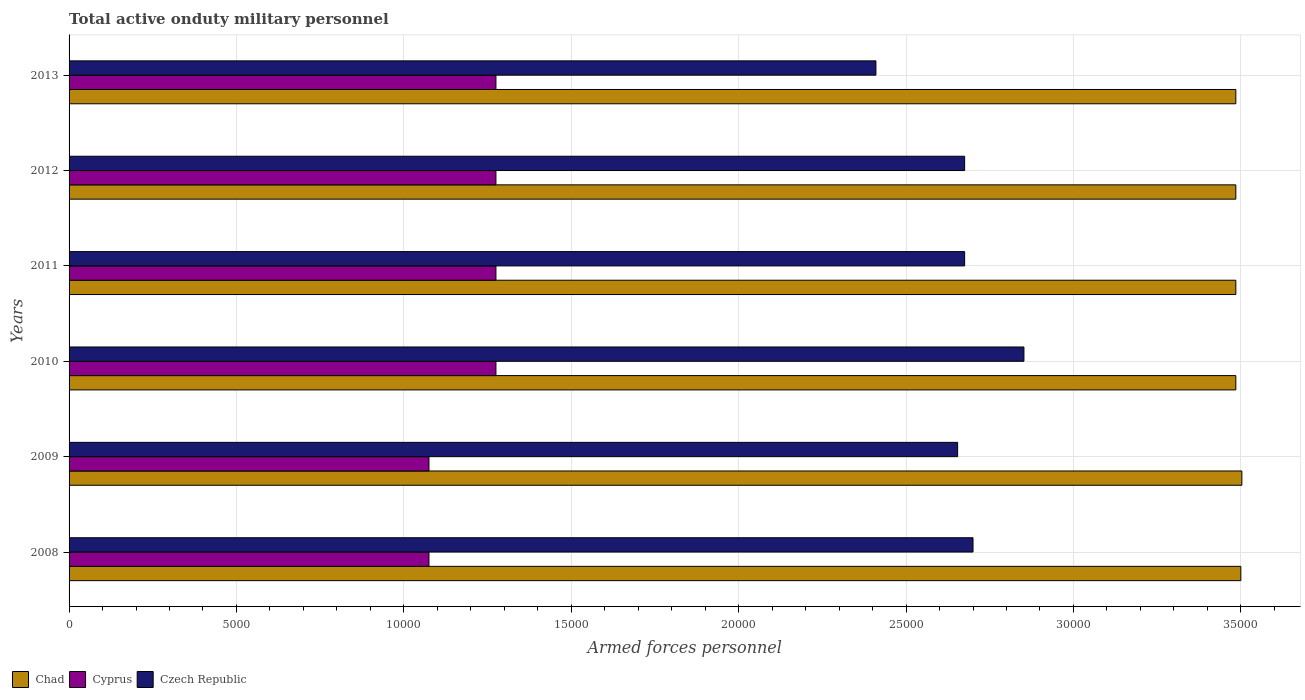How many different coloured bars are there?
Give a very brief answer. 3. Are the number of bars per tick equal to the number of legend labels?
Your answer should be compact. Yes. How many bars are there on the 4th tick from the bottom?
Your answer should be compact. 3. What is the number of armed forces personnel in Chad in 2011?
Provide a short and direct response. 3.48e+04. Across all years, what is the maximum number of armed forces personnel in Czech Republic?
Offer a very short reply. 2.85e+04. Across all years, what is the minimum number of armed forces personnel in Cyprus?
Your response must be concise. 1.08e+04. What is the total number of armed forces personnel in Cyprus in the graph?
Provide a short and direct response. 7.25e+04. What is the difference between the number of armed forces personnel in Cyprus in 2010 and that in 2012?
Your response must be concise. 0. What is the difference between the number of armed forces personnel in Czech Republic in 2010 and the number of armed forces personnel in Chad in 2008?
Offer a very short reply. -6479. What is the average number of armed forces personnel in Cyprus per year?
Make the answer very short. 1.21e+04. In the year 2008, what is the difference between the number of armed forces personnel in Cyprus and number of armed forces personnel in Czech Republic?
Ensure brevity in your answer.  -1.62e+04. In how many years, is the number of armed forces personnel in Cyprus greater than 10000 ?
Your response must be concise. 6. What is the ratio of the number of armed forces personnel in Cyprus in 2008 to that in 2010?
Your answer should be very brief. 0.84. Is the difference between the number of armed forces personnel in Cyprus in 2009 and 2012 greater than the difference between the number of armed forces personnel in Czech Republic in 2009 and 2012?
Your answer should be very brief. No. What is the difference between the highest and the second highest number of armed forces personnel in Cyprus?
Your answer should be compact. 0. What is the difference between the highest and the lowest number of armed forces personnel in Czech Republic?
Make the answer very short. 4421. In how many years, is the number of armed forces personnel in Czech Republic greater than the average number of armed forces personnel in Czech Republic taken over all years?
Make the answer very short. 4. What does the 3rd bar from the top in 2010 represents?
Ensure brevity in your answer.  Chad. What does the 3rd bar from the bottom in 2010 represents?
Your response must be concise. Czech Republic. How many years are there in the graph?
Your answer should be very brief. 6. What is the difference between two consecutive major ticks on the X-axis?
Give a very brief answer. 5000. Are the values on the major ticks of X-axis written in scientific E-notation?
Provide a succinct answer. No. Does the graph contain grids?
Your answer should be very brief. Yes. How many legend labels are there?
Ensure brevity in your answer.  3. How are the legend labels stacked?
Provide a succinct answer. Horizontal. What is the title of the graph?
Keep it short and to the point. Total active onduty military personnel. Does "Sint Maarten (Dutch part)" appear as one of the legend labels in the graph?
Ensure brevity in your answer.  No. What is the label or title of the X-axis?
Offer a very short reply. Armed forces personnel. What is the Armed forces personnel in Chad in 2008?
Offer a terse response. 3.50e+04. What is the Armed forces personnel of Cyprus in 2008?
Ensure brevity in your answer.  1.08e+04. What is the Armed forces personnel in Czech Republic in 2008?
Your response must be concise. 2.70e+04. What is the Armed forces personnel in Chad in 2009?
Provide a short and direct response. 3.50e+04. What is the Armed forces personnel in Cyprus in 2009?
Keep it short and to the point. 1.08e+04. What is the Armed forces personnel in Czech Republic in 2009?
Make the answer very short. 2.65e+04. What is the Armed forces personnel of Chad in 2010?
Your answer should be very brief. 3.48e+04. What is the Armed forces personnel of Cyprus in 2010?
Ensure brevity in your answer.  1.28e+04. What is the Armed forces personnel in Czech Republic in 2010?
Your answer should be compact. 2.85e+04. What is the Armed forces personnel of Chad in 2011?
Your answer should be very brief. 3.48e+04. What is the Armed forces personnel of Cyprus in 2011?
Give a very brief answer. 1.28e+04. What is the Armed forces personnel of Czech Republic in 2011?
Your answer should be compact. 2.68e+04. What is the Armed forces personnel in Chad in 2012?
Provide a succinct answer. 3.48e+04. What is the Armed forces personnel of Cyprus in 2012?
Offer a very short reply. 1.28e+04. What is the Armed forces personnel in Czech Republic in 2012?
Ensure brevity in your answer.  2.68e+04. What is the Armed forces personnel in Chad in 2013?
Your response must be concise. 3.48e+04. What is the Armed forces personnel of Cyprus in 2013?
Give a very brief answer. 1.28e+04. What is the Armed forces personnel of Czech Republic in 2013?
Your answer should be very brief. 2.41e+04. Across all years, what is the maximum Armed forces personnel in Chad?
Provide a short and direct response. 3.50e+04. Across all years, what is the maximum Armed forces personnel of Cyprus?
Make the answer very short. 1.28e+04. Across all years, what is the maximum Armed forces personnel of Czech Republic?
Give a very brief answer. 2.85e+04. Across all years, what is the minimum Armed forces personnel in Chad?
Offer a terse response. 3.48e+04. Across all years, what is the minimum Armed forces personnel in Cyprus?
Provide a succinct answer. 1.08e+04. Across all years, what is the minimum Armed forces personnel of Czech Republic?
Offer a terse response. 2.41e+04. What is the total Armed forces personnel in Chad in the graph?
Give a very brief answer. 2.09e+05. What is the total Armed forces personnel in Cyprus in the graph?
Provide a succinct answer. 7.25e+04. What is the total Armed forces personnel of Czech Republic in the graph?
Keep it short and to the point. 1.60e+05. What is the difference between the Armed forces personnel of Chad in 2008 and that in 2009?
Keep it short and to the point. -30. What is the difference between the Armed forces personnel in Cyprus in 2008 and that in 2009?
Your answer should be compact. 0. What is the difference between the Armed forces personnel of Czech Republic in 2008 and that in 2009?
Provide a short and direct response. 459. What is the difference between the Armed forces personnel of Chad in 2008 and that in 2010?
Ensure brevity in your answer.  150. What is the difference between the Armed forces personnel of Cyprus in 2008 and that in 2010?
Offer a very short reply. -2000. What is the difference between the Armed forces personnel of Czech Republic in 2008 and that in 2010?
Offer a terse response. -1521. What is the difference between the Armed forces personnel in Chad in 2008 and that in 2011?
Provide a succinct answer. 150. What is the difference between the Armed forces personnel in Cyprus in 2008 and that in 2011?
Keep it short and to the point. -2000. What is the difference between the Armed forces personnel of Czech Republic in 2008 and that in 2011?
Your response must be concise. 250. What is the difference between the Armed forces personnel of Chad in 2008 and that in 2012?
Your response must be concise. 150. What is the difference between the Armed forces personnel of Cyprus in 2008 and that in 2012?
Ensure brevity in your answer.  -2000. What is the difference between the Armed forces personnel in Czech Republic in 2008 and that in 2012?
Your answer should be very brief. 250. What is the difference between the Armed forces personnel of Chad in 2008 and that in 2013?
Offer a very short reply. 150. What is the difference between the Armed forces personnel in Cyprus in 2008 and that in 2013?
Your response must be concise. -2000. What is the difference between the Armed forces personnel in Czech Republic in 2008 and that in 2013?
Your response must be concise. 2900. What is the difference between the Armed forces personnel of Chad in 2009 and that in 2010?
Provide a succinct answer. 180. What is the difference between the Armed forces personnel of Cyprus in 2009 and that in 2010?
Keep it short and to the point. -2000. What is the difference between the Armed forces personnel in Czech Republic in 2009 and that in 2010?
Keep it short and to the point. -1980. What is the difference between the Armed forces personnel in Chad in 2009 and that in 2011?
Offer a very short reply. 180. What is the difference between the Armed forces personnel of Cyprus in 2009 and that in 2011?
Your answer should be compact. -2000. What is the difference between the Armed forces personnel in Czech Republic in 2009 and that in 2011?
Make the answer very short. -209. What is the difference between the Armed forces personnel of Chad in 2009 and that in 2012?
Your answer should be compact. 180. What is the difference between the Armed forces personnel of Cyprus in 2009 and that in 2012?
Your answer should be very brief. -2000. What is the difference between the Armed forces personnel of Czech Republic in 2009 and that in 2012?
Provide a short and direct response. -209. What is the difference between the Armed forces personnel in Chad in 2009 and that in 2013?
Make the answer very short. 180. What is the difference between the Armed forces personnel of Cyprus in 2009 and that in 2013?
Your answer should be compact. -2000. What is the difference between the Armed forces personnel of Czech Republic in 2009 and that in 2013?
Make the answer very short. 2441. What is the difference between the Armed forces personnel of Czech Republic in 2010 and that in 2011?
Your response must be concise. 1771. What is the difference between the Armed forces personnel in Cyprus in 2010 and that in 2012?
Provide a short and direct response. 0. What is the difference between the Armed forces personnel of Czech Republic in 2010 and that in 2012?
Ensure brevity in your answer.  1771. What is the difference between the Armed forces personnel of Chad in 2010 and that in 2013?
Make the answer very short. 0. What is the difference between the Armed forces personnel of Czech Republic in 2010 and that in 2013?
Offer a terse response. 4421. What is the difference between the Armed forces personnel in Chad in 2011 and that in 2013?
Provide a succinct answer. 0. What is the difference between the Armed forces personnel in Czech Republic in 2011 and that in 2013?
Keep it short and to the point. 2650. What is the difference between the Armed forces personnel in Chad in 2012 and that in 2013?
Your response must be concise. 0. What is the difference between the Armed forces personnel of Cyprus in 2012 and that in 2013?
Keep it short and to the point. 0. What is the difference between the Armed forces personnel in Czech Republic in 2012 and that in 2013?
Give a very brief answer. 2650. What is the difference between the Armed forces personnel in Chad in 2008 and the Armed forces personnel in Cyprus in 2009?
Offer a very short reply. 2.42e+04. What is the difference between the Armed forces personnel in Chad in 2008 and the Armed forces personnel in Czech Republic in 2009?
Give a very brief answer. 8459. What is the difference between the Armed forces personnel in Cyprus in 2008 and the Armed forces personnel in Czech Republic in 2009?
Make the answer very short. -1.58e+04. What is the difference between the Armed forces personnel of Chad in 2008 and the Armed forces personnel of Cyprus in 2010?
Offer a terse response. 2.22e+04. What is the difference between the Armed forces personnel of Chad in 2008 and the Armed forces personnel of Czech Republic in 2010?
Make the answer very short. 6479. What is the difference between the Armed forces personnel of Cyprus in 2008 and the Armed forces personnel of Czech Republic in 2010?
Ensure brevity in your answer.  -1.78e+04. What is the difference between the Armed forces personnel in Chad in 2008 and the Armed forces personnel in Cyprus in 2011?
Make the answer very short. 2.22e+04. What is the difference between the Armed forces personnel in Chad in 2008 and the Armed forces personnel in Czech Republic in 2011?
Keep it short and to the point. 8250. What is the difference between the Armed forces personnel of Cyprus in 2008 and the Armed forces personnel of Czech Republic in 2011?
Your answer should be very brief. -1.60e+04. What is the difference between the Armed forces personnel of Chad in 2008 and the Armed forces personnel of Cyprus in 2012?
Make the answer very short. 2.22e+04. What is the difference between the Armed forces personnel in Chad in 2008 and the Armed forces personnel in Czech Republic in 2012?
Ensure brevity in your answer.  8250. What is the difference between the Armed forces personnel of Cyprus in 2008 and the Armed forces personnel of Czech Republic in 2012?
Make the answer very short. -1.60e+04. What is the difference between the Armed forces personnel in Chad in 2008 and the Armed forces personnel in Cyprus in 2013?
Ensure brevity in your answer.  2.22e+04. What is the difference between the Armed forces personnel in Chad in 2008 and the Armed forces personnel in Czech Republic in 2013?
Your answer should be very brief. 1.09e+04. What is the difference between the Armed forces personnel in Cyprus in 2008 and the Armed forces personnel in Czech Republic in 2013?
Ensure brevity in your answer.  -1.34e+04. What is the difference between the Armed forces personnel of Chad in 2009 and the Armed forces personnel of Cyprus in 2010?
Offer a terse response. 2.23e+04. What is the difference between the Armed forces personnel in Chad in 2009 and the Armed forces personnel in Czech Republic in 2010?
Offer a very short reply. 6509. What is the difference between the Armed forces personnel of Cyprus in 2009 and the Armed forces personnel of Czech Republic in 2010?
Keep it short and to the point. -1.78e+04. What is the difference between the Armed forces personnel of Chad in 2009 and the Armed forces personnel of Cyprus in 2011?
Provide a short and direct response. 2.23e+04. What is the difference between the Armed forces personnel of Chad in 2009 and the Armed forces personnel of Czech Republic in 2011?
Your answer should be compact. 8280. What is the difference between the Armed forces personnel of Cyprus in 2009 and the Armed forces personnel of Czech Republic in 2011?
Keep it short and to the point. -1.60e+04. What is the difference between the Armed forces personnel in Chad in 2009 and the Armed forces personnel in Cyprus in 2012?
Your answer should be very brief. 2.23e+04. What is the difference between the Armed forces personnel in Chad in 2009 and the Armed forces personnel in Czech Republic in 2012?
Provide a succinct answer. 8280. What is the difference between the Armed forces personnel of Cyprus in 2009 and the Armed forces personnel of Czech Republic in 2012?
Offer a terse response. -1.60e+04. What is the difference between the Armed forces personnel in Chad in 2009 and the Armed forces personnel in Cyprus in 2013?
Offer a terse response. 2.23e+04. What is the difference between the Armed forces personnel of Chad in 2009 and the Armed forces personnel of Czech Republic in 2013?
Give a very brief answer. 1.09e+04. What is the difference between the Armed forces personnel of Cyprus in 2009 and the Armed forces personnel of Czech Republic in 2013?
Ensure brevity in your answer.  -1.34e+04. What is the difference between the Armed forces personnel in Chad in 2010 and the Armed forces personnel in Cyprus in 2011?
Your answer should be compact. 2.21e+04. What is the difference between the Armed forces personnel of Chad in 2010 and the Armed forces personnel of Czech Republic in 2011?
Make the answer very short. 8100. What is the difference between the Armed forces personnel in Cyprus in 2010 and the Armed forces personnel in Czech Republic in 2011?
Offer a terse response. -1.40e+04. What is the difference between the Armed forces personnel of Chad in 2010 and the Armed forces personnel of Cyprus in 2012?
Provide a short and direct response. 2.21e+04. What is the difference between the Armed forces personnel of Chad in 2010 and the Armed forces personnel of Czech Republic in 2012?
Provide a short and direct response. 8100. What is the difference between the Armed forces personnel of Cyprus in 2010 and the Armed forces personnel of Czech Republic in 2012?
Offer a terse response. -1.40e+04. What is the difference between the Armed forces personnel in Chad in 2010 and the Armed forces personnel in Cyprus in 2013?
Your answer should be compact. 2.21e+04. What is the difference between the Armed forces personnel of Chad in 2010 and the Armed forces personnel of Czech Republic in 2013?
Offer a terse response. 1.08e+04. What is the difference between the Armed forces personnel of Cyprus in 2010 and the Armed forces personnel of Czech Republic in 2013?
Provide a short and direct response. -1.14e+04. What is the difference between the Armed forces personnel of Chad in 2011 and the Armed forces personnel of Cyprus in 2012?
Make the answer very short. 2.21e+04. What is the difference between the Armed forces personnel of Chad in 2011 and the Armed forces personnel of Czech Republic in 2012?
Your answer should be very brief. 8100. What is the difference between the Armed forces personnel of Cyprus in 2011 and the Armed forces personnel of Czech Republic in 2012?
Offer a very short reply. -1.40e+04. What is the difference between the Armed forces personnel in Chad in 2011 and the Armed forces personnel in Cyprus in 2013?
Make the answer very short. 2.21e+04. What is the difference between the Armed forces personnel in Chad in 2011 and the Armed forces personnel in Czech Republic in 2013?
Your answer should be compact. 1.08e+04. What is the difference between the Armed forces personnel of Cyprus in 2011 and the Armed forces personnel of Czech Republic in 2013?
Give a very brief answer. -1.14e+04. What is the difference between the Armed forces personnel in Chad in 2012 and the Armed forces personnel in Cyprus in 2013?
Your answer should be very brief. 2.21e+04. What is the difference between the Armed forces personnel in Chad in 2012 and the Armed forces personnel in Czech Republic in 2013?
Give a very brief answer. 1.08e+04. What is the difference between the Armed forces personnel of Cyprus in 2012 and the Armed forces personnel of Czech Republic in 2013?
Provide a short and direct response. -1.14e+04. What is the average Armed forces personnel of Chad per year?
Offer a terse response. 3.49e+04. What is the average Armed forces personnel in Cyprus per year?
Provide a succinct answer. 1.21e+04. What is the average Armed forces personnel in Czech Republic per year?
Your answer should be compact. 2.66e+04. In the year 2008, what is the difference between the Armed forces personnel of Chad and Armed forces personnel of Cyprus?
Offer a very short reply. 2.42e+04. In the year 2008, what is the difference between the Armed forces personnel in Chad and Armed forces personnel in Czech Republic?
Provide a short and direct response. 8000. In the year 2008, what is the difference between the Armed forces personnel of Cyprus and Armed forces personnel of Czech Republic?
Keep it short and to the point. -1.62e+04. In the year 2009, what is the difference between the Armed forces personnel in Chad and Armed forces personnel in Cyprus?
Your answer should be very brief. 2.43e+04. In the year 2009, what is the difference between the Armed forces personnel of Chad and Armed forces personnel of Czech Republic?
Your response must be concise. 8489. In the year 2009, what is the difference between the Armed forces personnel of Cyprus and Armed forces personnel of Czech Republic?
Keep it short and to the point. -1.58e+04. In the year 2010, what is the difference between the Armed forces personnel of Chad and Armed forces personnel of Cyprus?
Provide a succinct answer. 2.21e+04. In the year 2010, what is the difference between the Armed forces personnel of Chad and Armed forces personnel of Czech Republic?
Give a very brief answer. 6329. In the year 2010, what is the difference between the Armed forces personnel in Cyprus and Armed forces personnel in Czech Republic?
Offer a very short reply. -1.58e+04. In the year 2011, what is the difference between the Armed forces personnel of Chad and Armed forces personnel of Cyprus?
Your answer should be compact. 2.21e+04. In the year 2011, what is the difference between the Armed forces personnel of Chad and Armed forces personnel of Czech Republic?
Your response must be concise. 8100. In the year 2011, what is the difference between the Armed forces personnel of Cyprus and Armed forces personnel of Czech Republic?
Offer a terse response. -1.40e+04. In the year 2012, what is the difference between the Armed forces personnel of Chad and Armed forces personnel of Cyprus?
Make the answer very short. 2.21e+04. In the year 2012, what is the difference between the Armed forces personnel in Chad and Armed forces personnel in Czech Republic?
Offer a terse response. 8100. In the year 2012, what is the difference between the Armed forces personnel in Cyprus and Armed forces personnel in Czech Republic?
Provide a short and direct response. -1.40e+04. In the year 2013, what is the difference between the Armed forces personnel of Chad and Armed forces personnel of Cyprus?
Offer a terse response. 2.21e+04. In the year 2013, what is the difference between the Armed forces personnel of Chad and Armed forces personnel of Czech Republic?
Make the answer very short. 1.08e+04. In the year 2013, what is the difference between the Armed forces personnel in Cyprus and Armed forces personnel in Czech Republic?
Provide a succinct answer. -1.14e+04. What is the ratio of the Armed forces personnel in Czech Republic in 2008 to that in 2009?
Your answer should be very brief. 1.02. What is the ratio of the Armed forces personnel in Chad in 2008 to that in 2010?
Your answer should be compact. 1. What is the ratio of the Armed forces personnel of Cyprus in 2008 to that in 2010?
Give a very brief answer. 0.84. What is the ratio of the Armed forces personnel of Czech Republic in 2008 to that in 2010?
Give a very brief answer. 0.95. What is the ratio of the Armed forces personnel in Chad in 2008 to that in 2011?
Provide a short and direct response. 1. What is the ratio of the Armed forces personnel in Cyprus in 2008 to that in 2011?
Give a very brief answer. 0.84. What is the ratio of the Armed forces personnel of Czech Republic in 2008 to that in 2011?
Your answer should be very brief. 1.01. What is the ratio of the Armed forces personnel in Cyprus in 2008 to that in 2012?
Offer a terse response. 0.84. What is the ratio of the Armed forces personnel in Czech Republic in 2008 to that in 2012?
Make the answer very short. 1.01. What is the ratio of the Armed forces personnel in Chad in 2008 to that in 2013?
Keep it short and to the point. 1. What is the ratio of the Armed forces personnel of Cyprus in 2008 to that in 2013?
Make the answer very short. 0.84. What is the ratio of the Armed forces personnel of Czech Republic in 2008 to that in 2013?
Keep it short and to the point. 1.12. What is the ratio of the Armed forces personnel in Cyprus in 2009 to that in 2010?
Your answer should be very brief. 0.84. What is the ratio of the Armed forces personnel of Czech Republic in 2009 to that in 2010?
Ensure brevity in your answer.  0.93. What is the ratio of the Armed forces personnel of Cyprus in 2009 to that in 2011?
Keep it short and to the point. 0.84. What is the ratio of the Armed forces personnel in Czech Republic in 2009 to that in 2011?
Make the answer very short. 0.99. What is the ratio of the Armed forces personnel in Chad in 2009 to that in 2012?
Offer a very short reply. 1.01. What is the ratio of the Armed forces personnel in Cyprus in 2009 to that in 2012?
Offer a terse response. 0.84. What is the ratio of the Armed forces personnel of Cyprus in 2009 to that in 2013?
Offer a very short reply. 0.84. What is the ratio of the Armed forces personnel in Czech Republic in 2009 to that in 2013?
Your answer should be very brief. 1.1. What is the ratio of the Armed forces personnel of Cyprus in 2010 to that in 2011?
Your answer should be very brief. 1. What is the ratio of the Armed forces personnel of Czech Republic in 2010 to that in 2011?
Provide a short and direct response. 1.07. What is the ratio of the Armed forces personnel of Chad in 2010 to that in 2012?
Your answer should be very brief. 1. What is the ratio of the Armed forces personnel of Czech Republic in 2010 to that in 2012?
Provide a succinct answer. 1.07. What is the ratio of the Armed forces personnel of Cyprus in 2010 to that in 2013?
Offer a very short reply. 1. What is the ratio of the Armed forces personnel in Czech Republic in 2010 to that in 2013?
Provide a short and direct response. 1.18. What is the ratio of the Armed forces personnel of Chad in 2011 to that in 2012?
Your answer should be very brief. 1. What is the ratio of the Armed forces personnel in Czech Republic in 2011 to that in 2012?
Your response must be concise. 1. What is the ratio of the Armed forces personnel of Chad in 2011 to that in 2013?
Offer a very short reply. 1. What is the ratio of the Armed forces personnel of Czech Republic in 2011 to that in 2013?
Make the answer very short. 1.11. What is the ratio of the Armed forces personnel of Cyprus in 2012 to that in 2013?
Provide a succinct answer. 1. What is the ratio of the Armed forces personnel in Czech Republic in 2012 to that in 2013?
Keep it short and to the point. 1.11. What is the difference between the highest and the second highest Armed forces personnel of Chad?
Make the answer very short. 30. What is the difference between the highest and the second highest Armed forces personnel in Czech Republic?
Make the answer very short. 1521. What is the difference between the highest and the lowest Armed forces personnel in Chad?
Your answer should be compact. 180. What is the difference between the highest and the lowest Armed forces personnel in Czech Republic?
Ensure brevity in your answer.  4421. 